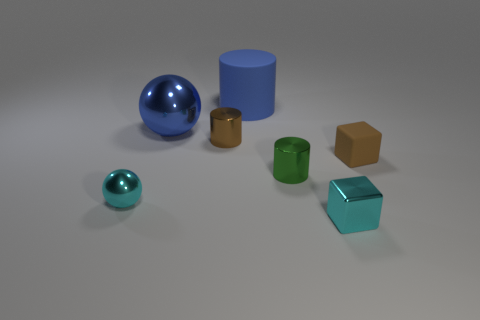There is a cyan thing that is to the left of the rubber cylinder; does it have the same size as the brown rubber block?
Provide a short and direct response. Yes. Are there any small matte objects of the same color as the large metallic sphere?
Make the answer very short. No. What number of things are brown objects that are to the right of the small brown metal thing or objects that are left of the blue rubber thing?
Your response must be concise. 4. Is the color of the matte cylinder the same as the big metal ball?
Offer a terse response. Yes. There is a big object that is the same color as the large sphere; what material is it?
Keep it short and to the point. Rubber. Are there fewer small green shiny cylinders in front of the green metallic cylinder than metal objects in front of the matte block?
Offer a very short reply. Yes. Are the small green cylinder and the blue ball made of the same material?
Your response must be concise. Yes. What is the size of the object that is on the right side of the green cylinder and in front of the small brown block?
Your response must be concise. Small. What shape is the green object that is the same size as the cyan cube?
Offer a terse response. Cylinder. There is a small thing that is to the right of the small cyan shiny object on the right side of the tiny green object that is in front of the tiny brown metal cylinder; what is it made of?
Make the answer very short. Rubber. 